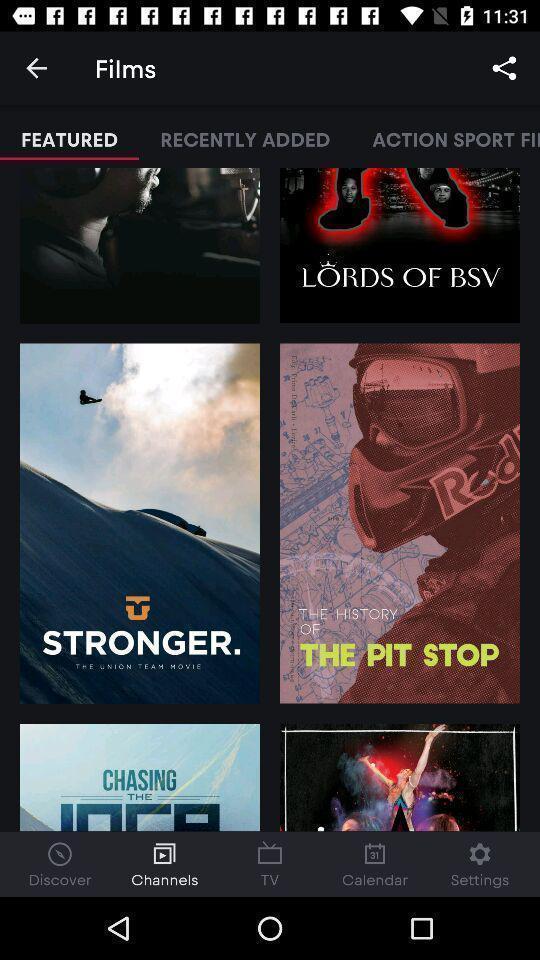Describe the key features of this screenshot. Page with featured channels in a tv app. 